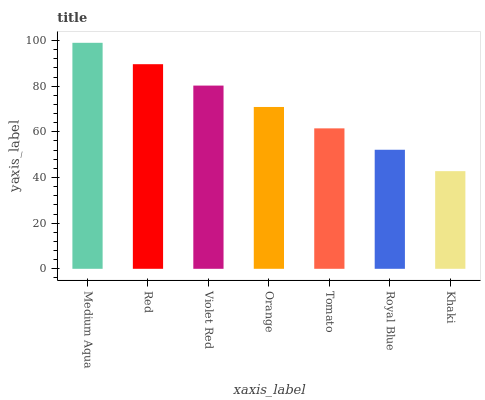Is Khaki the minimum?
Answer yes or no. Yes. Is Medium Aqua the maximum?
Answer yes or no. Yes. Is Red the minimum?
Answer yes or no. No. Is Red the maximum?
Answer yes or no. No. Is Medium Aqua greater than Red?
Answer yes or no. Yes. Is Red less than Medium Aqua?
Answer yes or no. Yes. Is Red greater than Medium Aqua?
Answer yes or no. No. Is Medium Aqua less than Red?
Answer yes or no. No. Is Orange the high median?
Answer yes or no. Yes. Is Orange the low median?
Answer yes or no. Yes. Is Medium Aqua the high median?
Answer yes or no. No. Is Tomato the low median?
Answer yes or no. No. 